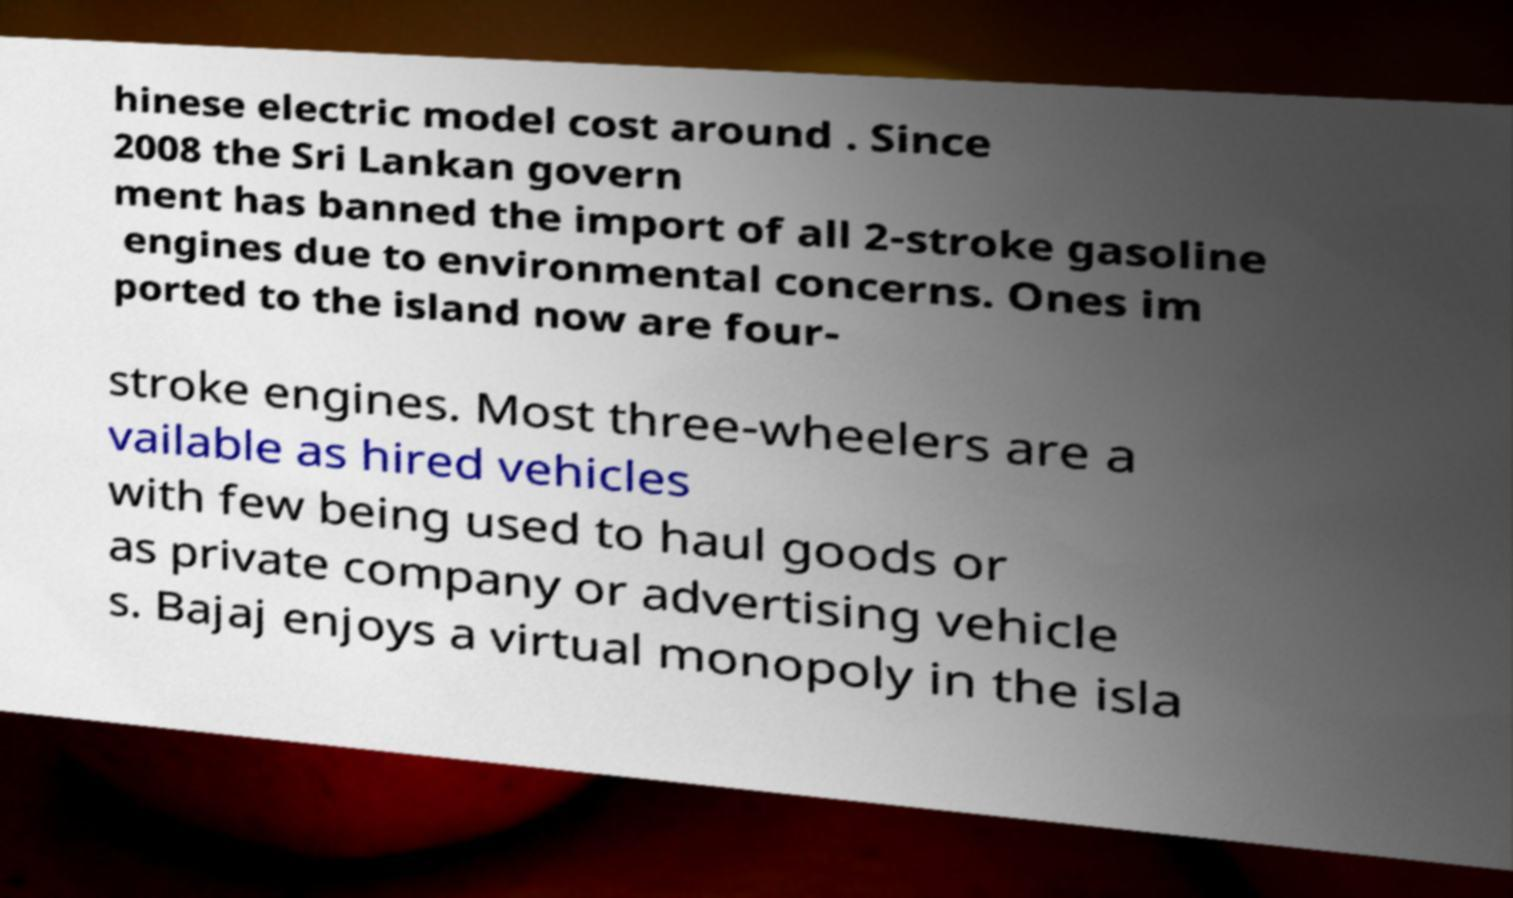What messages or text are displayed in this image? I need them in a readable, typed format. hinese electric model cost around . Since 2008 the Sri Lankan govern ment has banned the import of all 2-stroke gasoline engines due to environmental concerns. Ones im ported to the island now are four- stroke engines. Most three-wheelers are a vailable as hired vehicles with few being used to haul goods or as private company or advertising vehicle s. Bajaj enjoys a virtual monopoly in the isla 